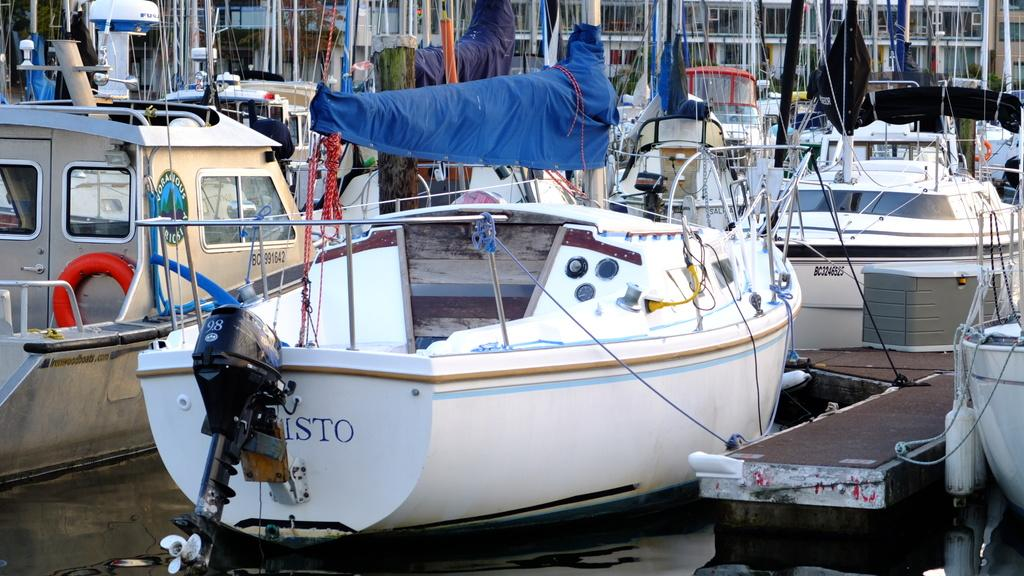What is in the water in the image? There are boats in the water in the image. What can be seen in the background of the image? There are buildings in the background of the image. How many women are visible in the image? There are no women present in the image; it features boats in the water and buildings in the background. What mark can be seen on the boats in the image? There is no mention of any marks on the boats in the image. 